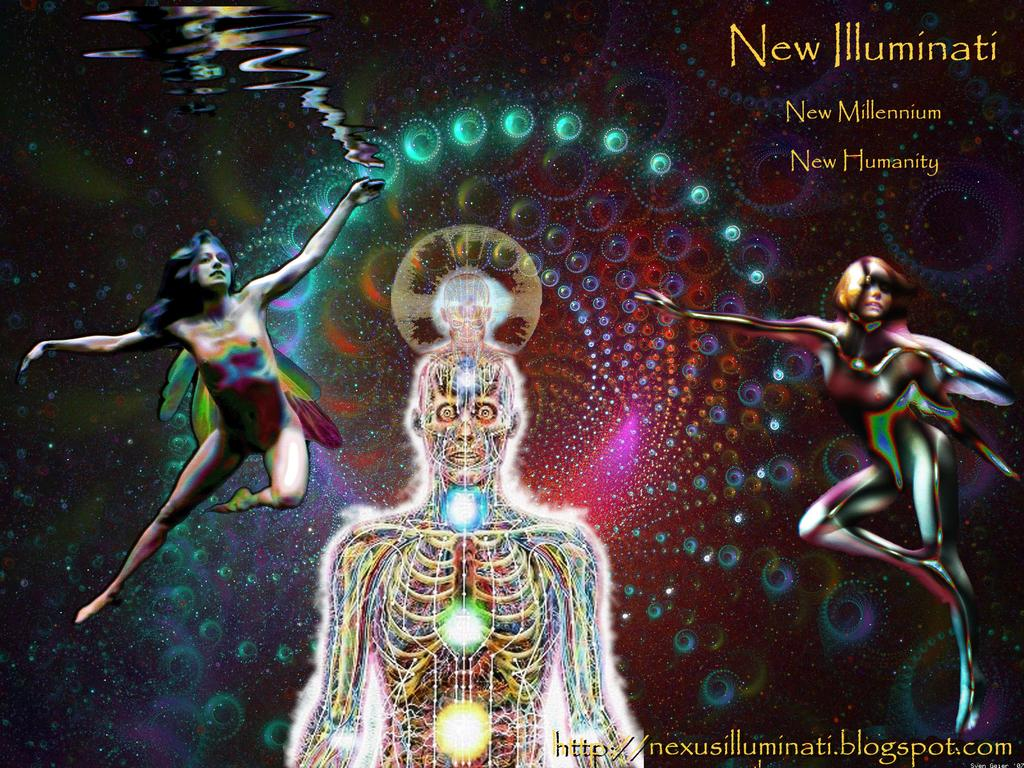<image>
Offer a succinct explanation of the picture presented. A poster features images of the New Millennium and the New Humanity. 